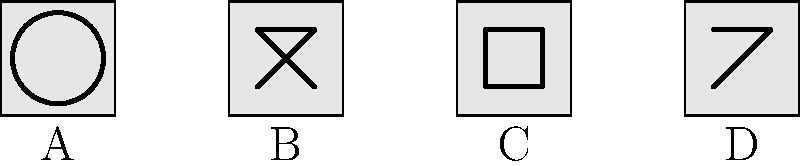Which of the traditional Limpopo tribal patterns shown above is associated with unity and strength in the community? To answer this question, we need to analyze each pattern and its symbolic meaning in Limpopo tribal culture:

1. Pattern A: This pattern shows a circle within a square. In many African cultures, including those in Limpopo, the circle represents unity, wholeness, and the cycle of life. The square surrounding it can symbolize stability and protection.

2. Pattern B: This pattern displays an X-shape or cross. In some Limpopo tribes, this symbol can represent crossroads or important decisions, but it's not typically associated with unity and strength.

3. Pattern C: This pattern shows a square within a square. While it might represent structure or organization, it's not commonly linked to unity and strength in Limpopo tribal symbolism.

4. Pattern D: This pattern depicts a triangle. Triangles in some African cultures can represent leadership or hierarchy, but they're not usually associated with unity and strength in Limpopo traditions.

Given these interpretations, Pattern A with the circle inside the square is the most likely to represent unity and strength in the community. The circle symbolizes unity, while the square adds the element of strength and protection around that unity.
Answer: A 